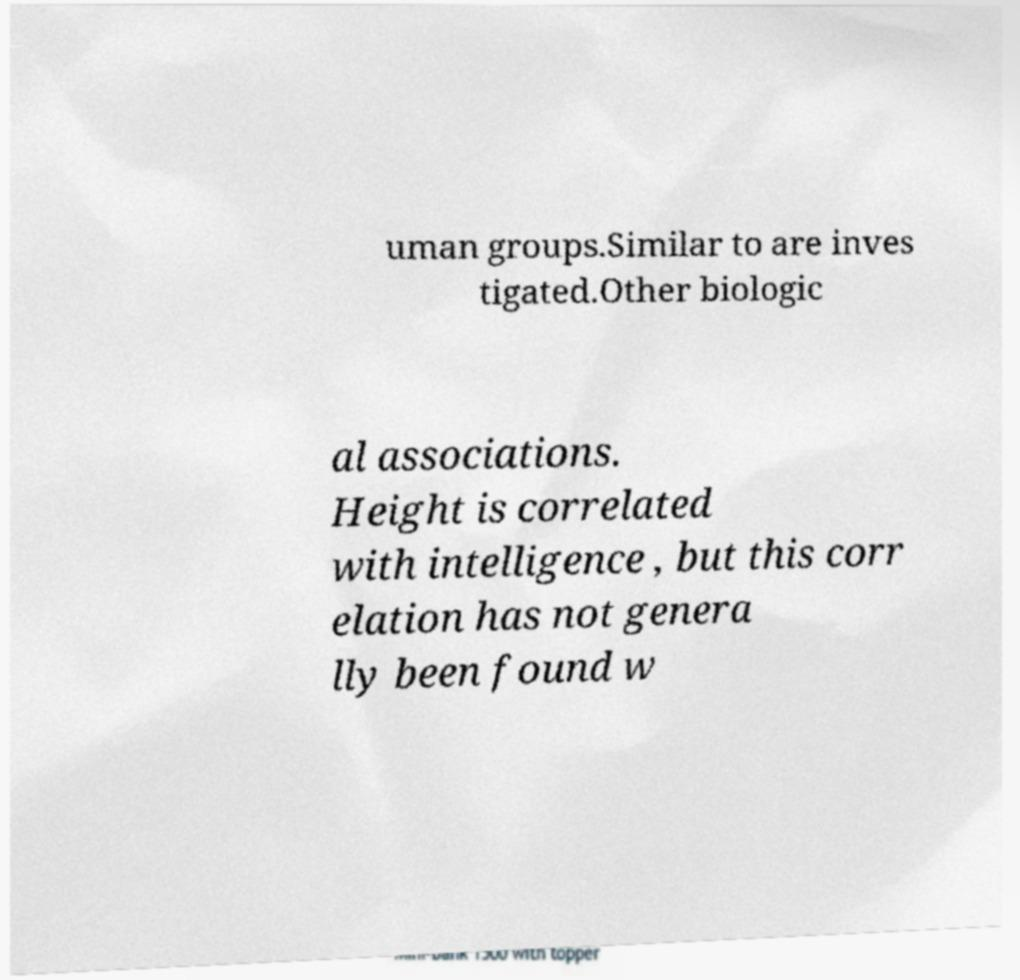Can you read and provide the text displayed in the image?This photo seems to have some interesting text. Can you extract and type it out for me? uman groups.Similar to are inves tigated.Other biologic al associations. Height is correlated with intelligence , but this corr elation has not genera lly been found w 